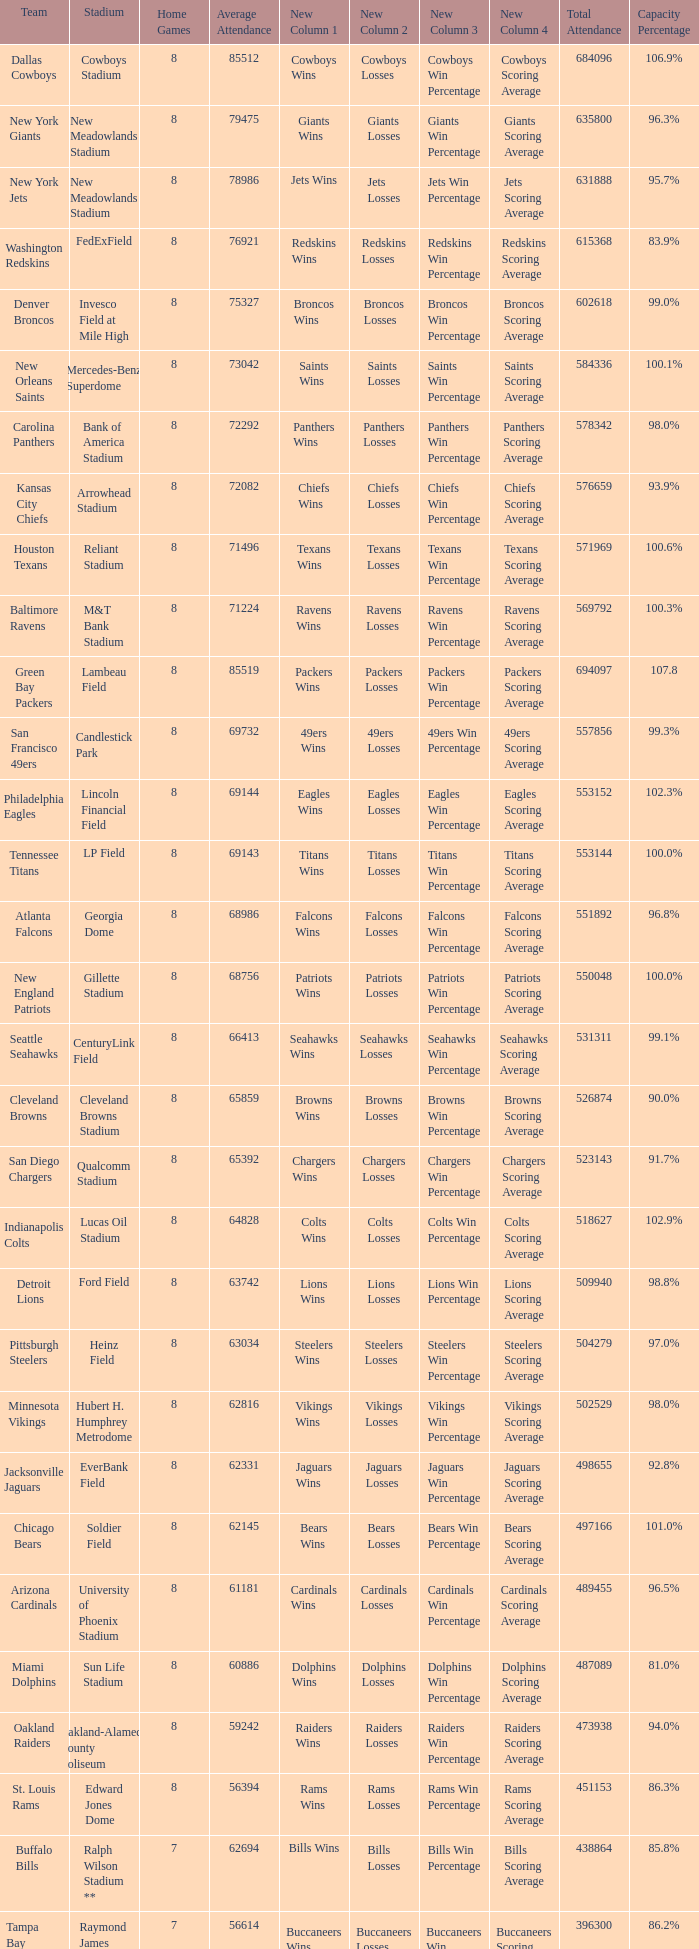What is the number listed in home games when the team is Seattle Seahawks? 8.0. 